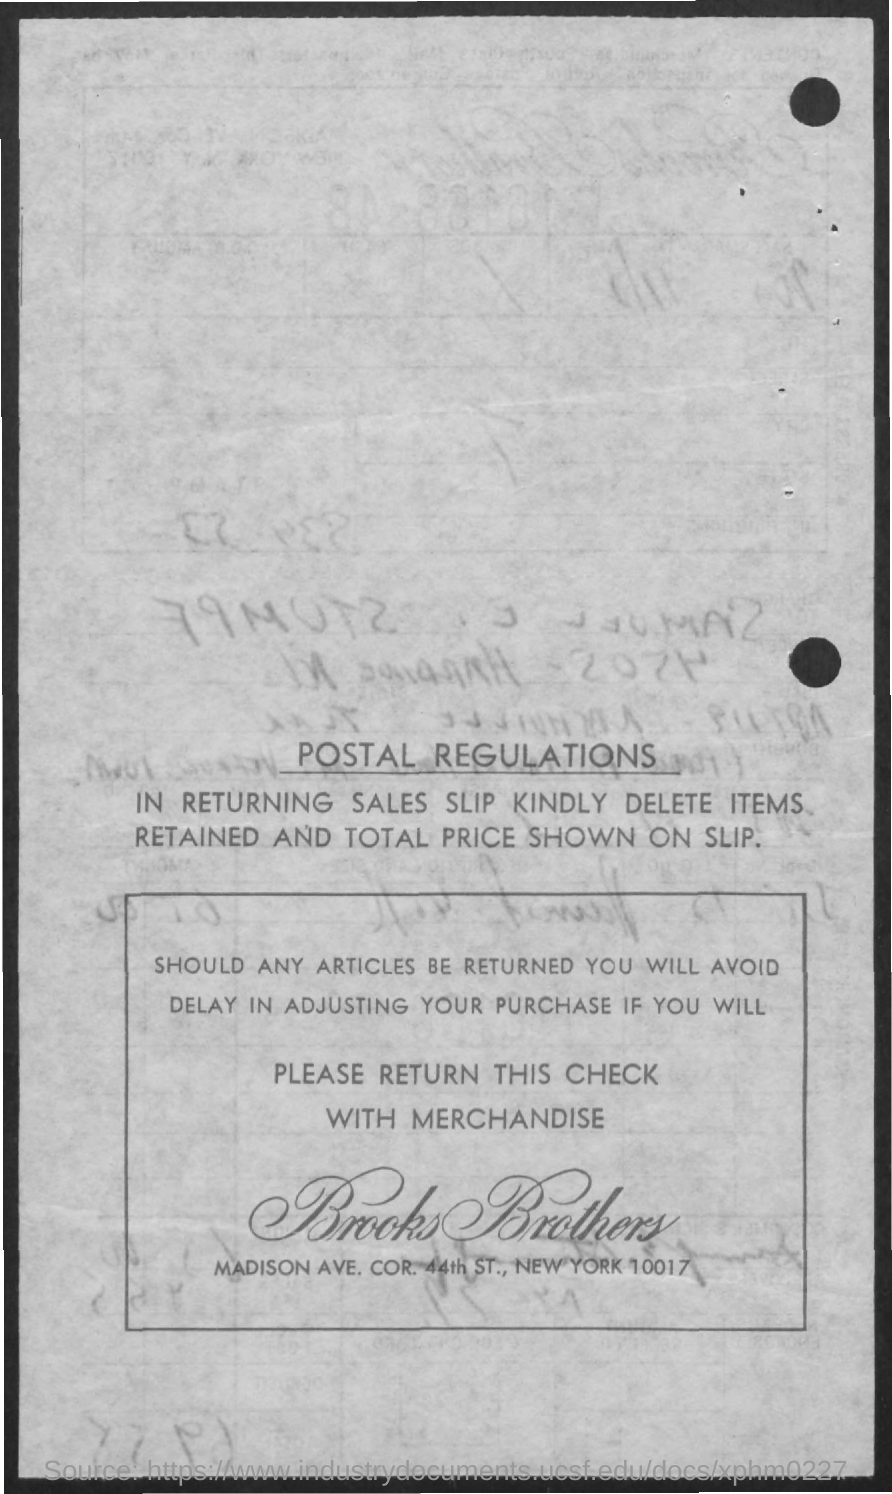Indicate a few pertinent items in this graphic. The name of the company mentioned in the document is Brooks Brothers. The first title in the document is 'Postal Regulations.' 